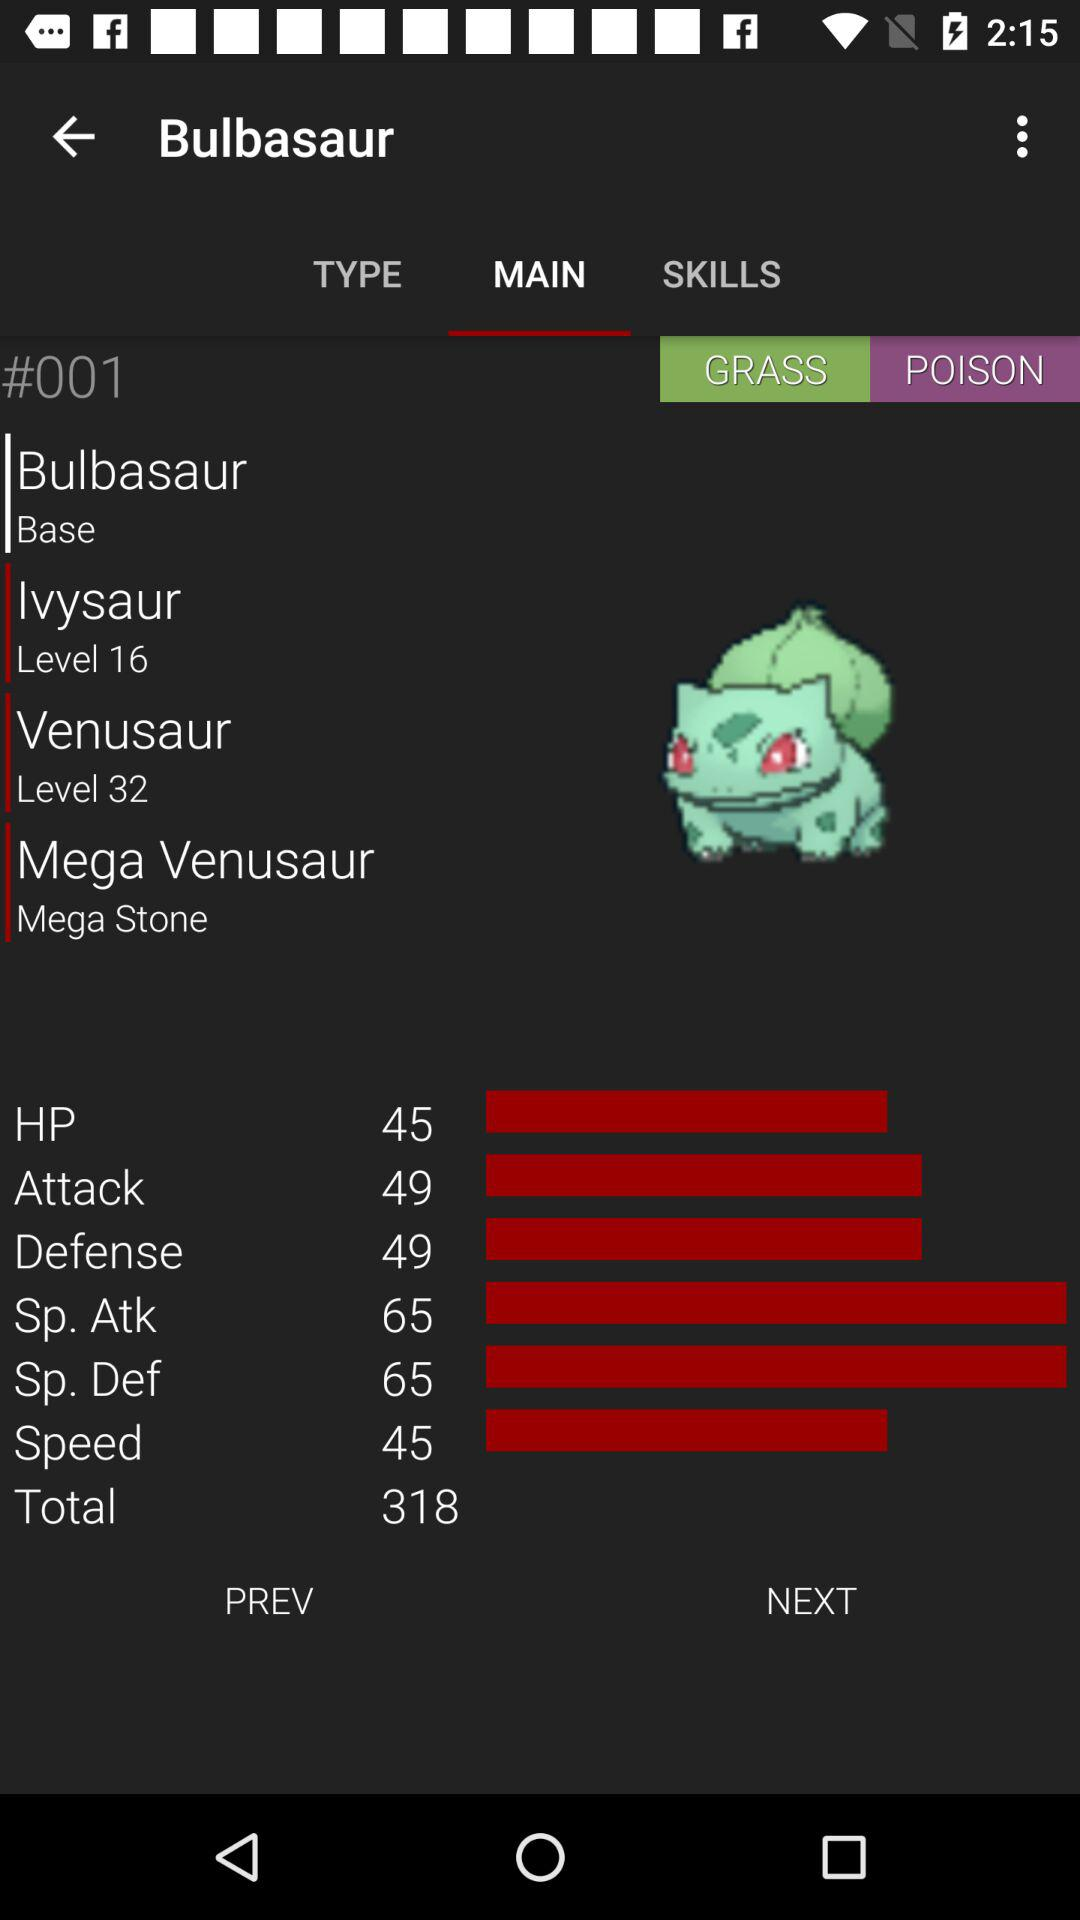What is the total of Bulbasaur's HP, Attack, Defense, Sp. Atk, Sp. Def, and Speed stats?
Answer the question using a single word or phrase. 318 